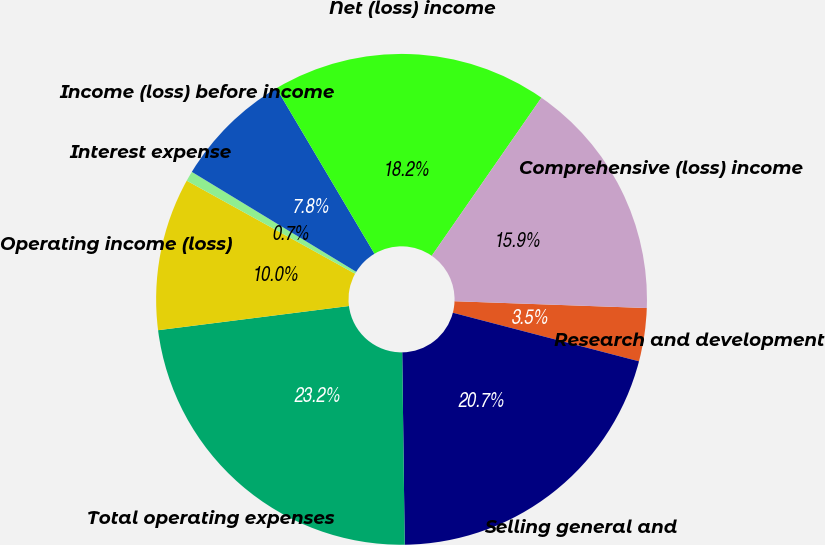<chart> <loc_0><loc_0><loc_500><loc_500><pie_chart><fcel>Research and development<fcel>Selling general and<fcel>Total operating expenses<fcel>Operating income (loss)<fcel>Interest expense<fcel>Income (loss) before income<fcel>Net (loss) income<fcel>Comprehensive (loss) income<nl><fcel>3.5%<fcel>20.73%<fcel>23.2%<fcel>10.04%<fcel>0.66%<fcel>7.79%<fcel>18.17%<fcel>15.91%<nl></chart> 